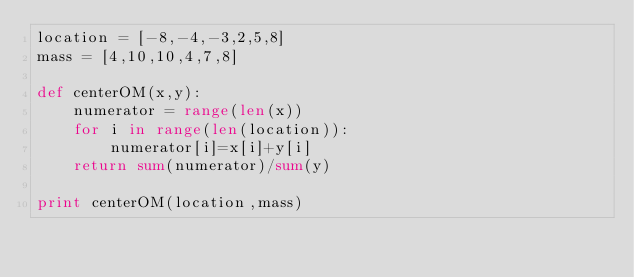Convert code to text. <code><loc_0><loc_0><loc_500><loc_500><_Python_>location = [-8,-4,-3,2,5,8]
mass = [4,10,10,4,7,8]

def centerOM(x,y):
    numerator = range(len(x))
    for i in range(len(location)):
        numerator[i]=x[i]+y[i]
    return sum(numerator)/sum(y)

print centerOM(location,mass)
</code> 